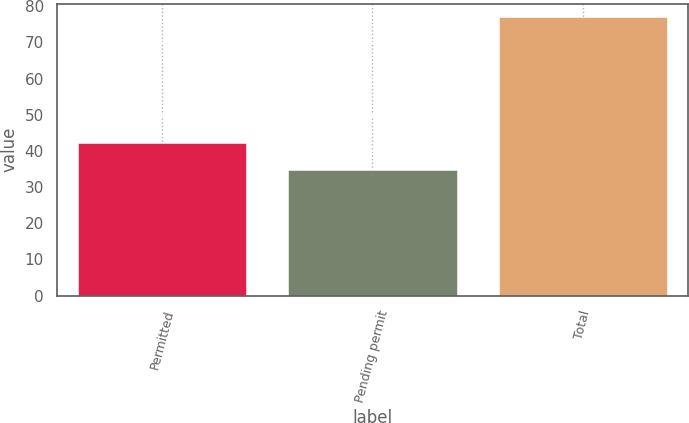Convert chart to OTSL. <chart><loc_0><loc_0><loc_500><loc_500><bar_chart><fcel>Permitted<fcel>Pending permit<fcel>Total<nl><fcel>42.2<fcel>34.7<fcel>76.9<nl></chart> 